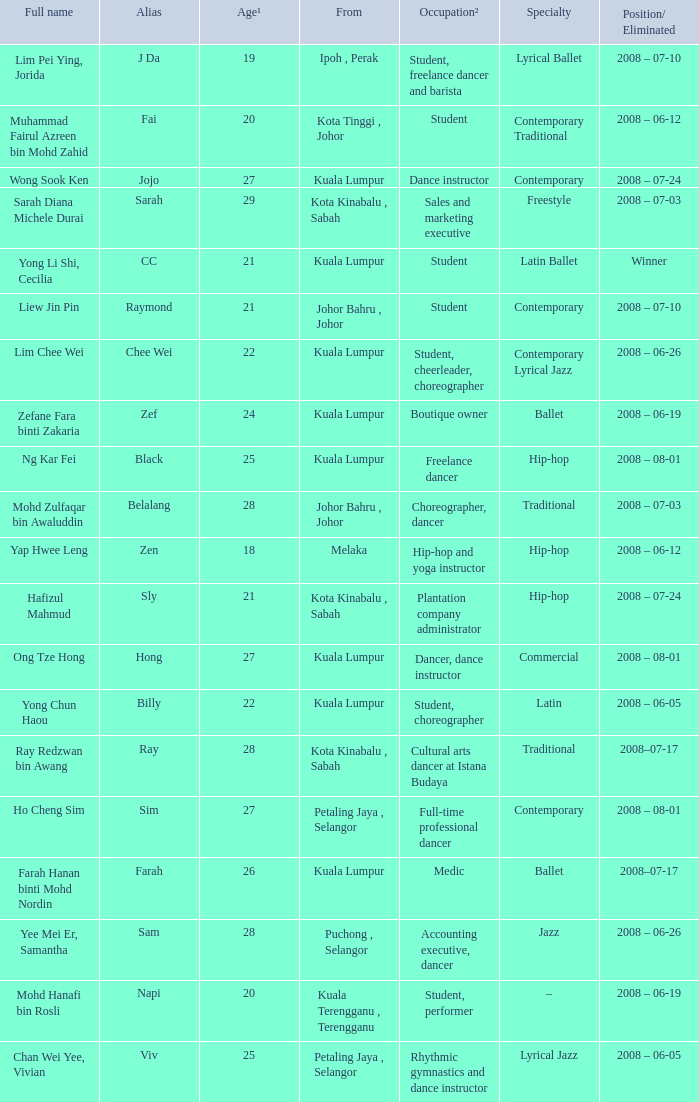What is Position/ Eliminated, when Age¹ is less than 22, and when Full Name is "Muhammad Fairul Azreen Bin Mohd Zahid"? 2008 – 06-12. 